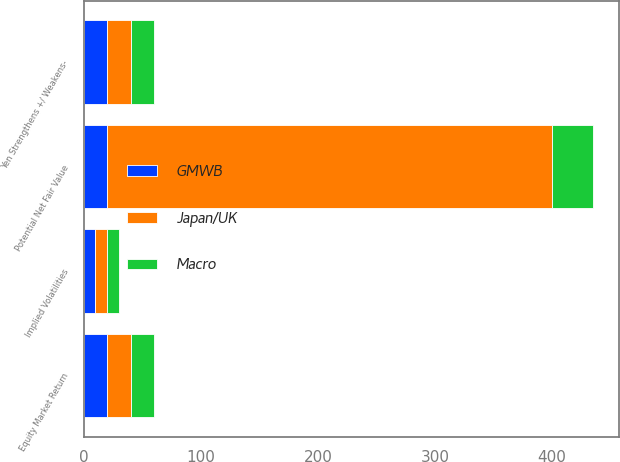<chart> <loc_0><loc_0><loc_500><loc_500><stacked_bar_chart><ecel><fcel>Equity Market Return<fcel>Potential Net Fair Value<fcel>Implied Volatilities<fcel>Yen Strengthens +/ Weakens-<nl><fcel>Macro<fcel>20<fcel>35<fcel>10<fcel>20<nl><fcel>Japan/UK<fcel>20<fcel>380<fcel>10<fcel>20<nl><fcel>GMWB<fcel>20<fcel>20<fcel>10<fcel>20<nl></chart> 